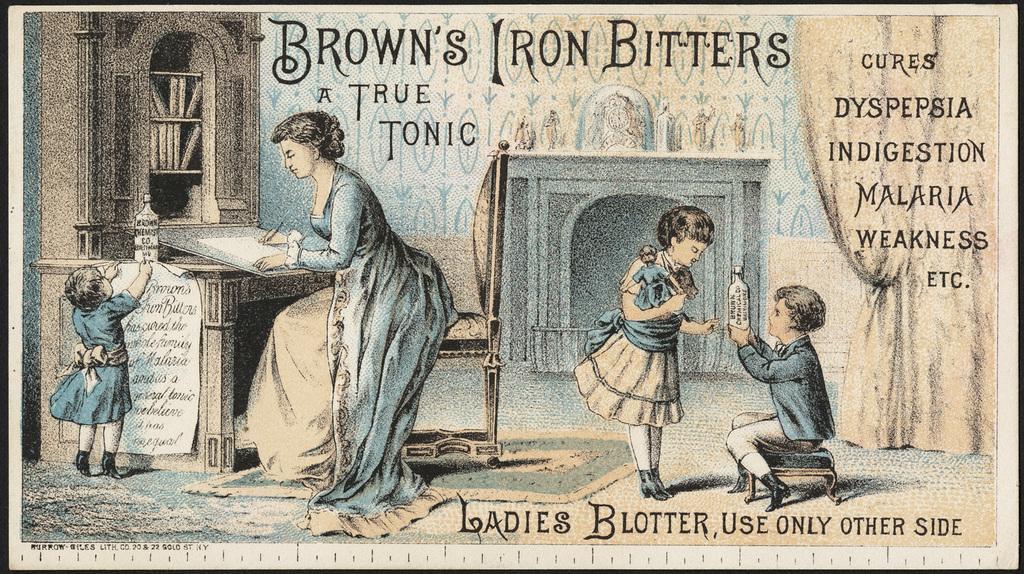Describe this image in one or two sentences. In this image there is a paper. On the paper there is text. There are images of a few people. There is a woman sitting on a chair at the table. She is writing on a paper. Beside her there is a girl sticking a paper to the table. On the table there is a bottle. To the left there is a rack and there are books in the rack. In the center there is a boy sitting on the stool and holding a bottle in his hand. In front of him there is a girl holding a doll. Behind them there is a fireplace. To the right there is a curtain. 